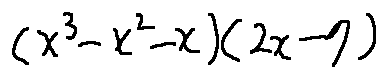<formula> <loc_0><loc_0><loc_500><loc_500>( x ^ { 3 } - x ^ { 2 } - x ) ( 2 x - 7 )</formula> 